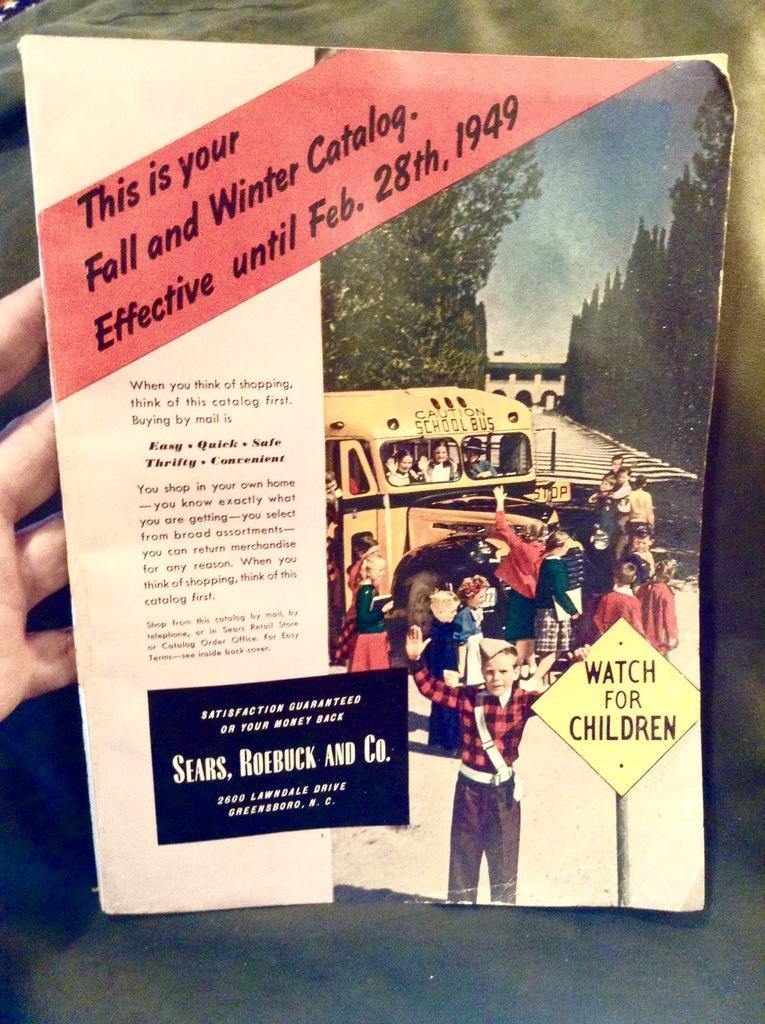Please provide a concise description of this image. In this image, on the left side, we can see hand of a person. In the middle of the image, we can see a book. In the background, we can see green color. 